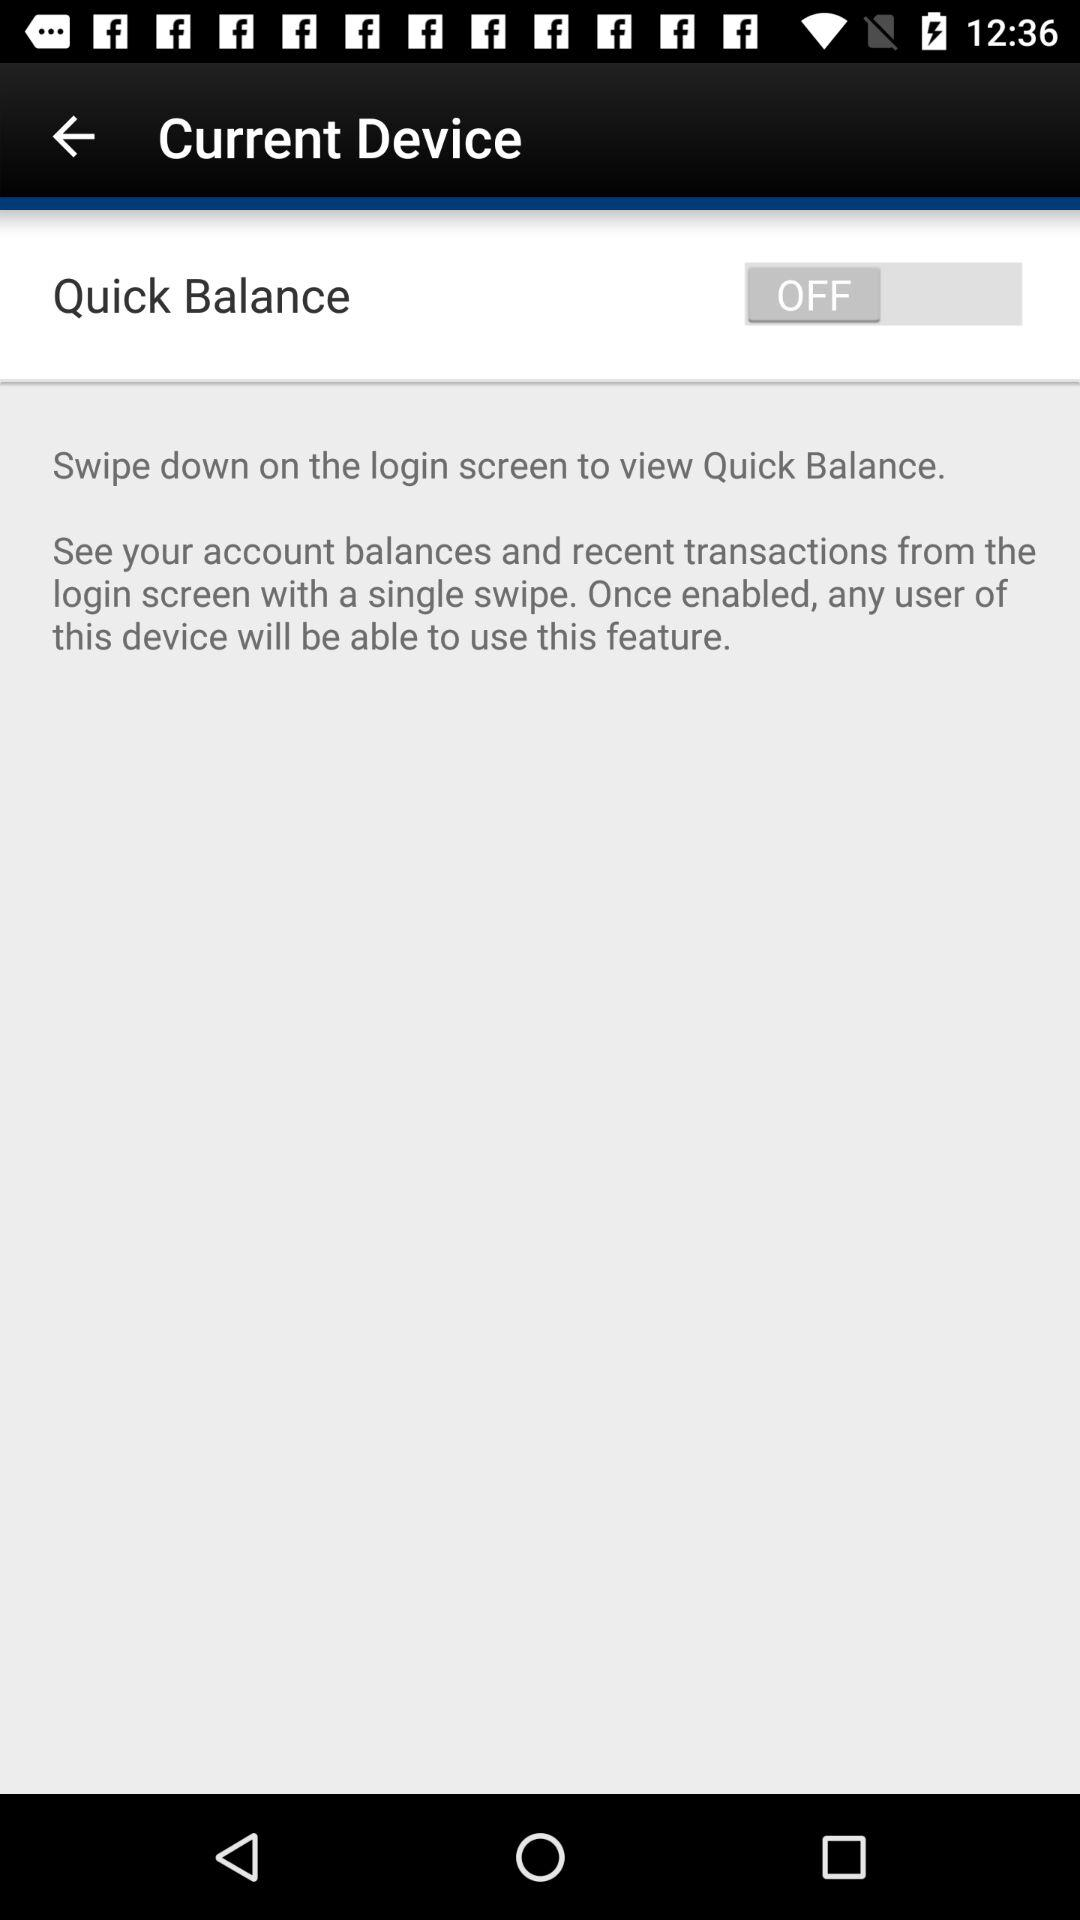What is the status of "Quick Balance"? The status is "off". 